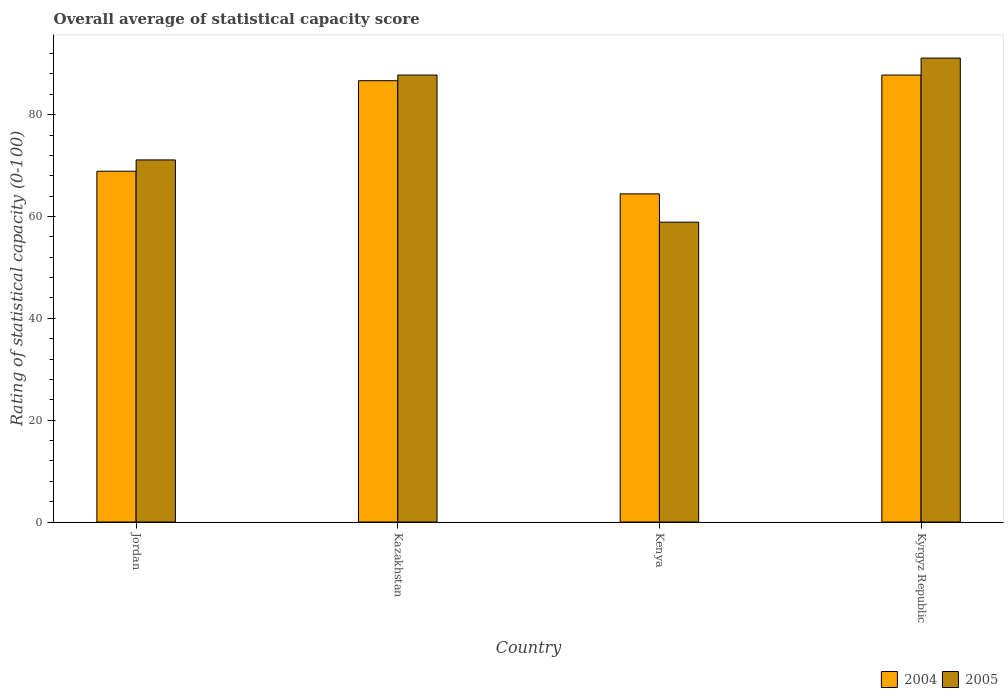How many different coloured bars are there?
Your response must be concise. 2. How many groups of bars are there?
Your answer should be compact. 4. Are the number of bars per tick equal to the number of legend labels?
Provide a short and direct response. Yes. What is the label of the 4th group of bars from the left?
Your answer should be very brief. Kyrgyz Republic. What is the rating of statistical capacity in 2005 in Kazakhstan?
Make the answer very short. 87.78. Across all countries, what is the maximum rating of statistical capacity in 2004?
Your answer should be compact. 87.78. Across all countries, what is the minimum rating of statistical capacity in 2005?
Your answer should be compact. 58.89. In which country was the rating of statistical capacity in 2004 maximum?
Keep it short and to the point. Kyrgyz Republic. In which country was the rating of statistical capacity in 2005 minimum?
Your answer should be compact. Kenya. What is the total rating of statistical capacity in 2005 in the graph?
Offer a very short reply. 308.89. What is the difference between the rating of statistical capacity in 2004 in Kazakhstan and that in Kyrgyz Republic?
Provide a short and direct response. -1.11. What is the difference between the rating of statistical capacity in 2005 in Jordan and the rating of statistical capacity in 2004 in Kyrgyz Republic?
Ensure brevity in your answer.  -16.67. What is the average rating of statistical capacity in 2005 per country?
Ensure brevity in your answer.  77.22. What is the difference between the rating of statistical capacity of/in 2004 and rating of statistical capacity of/in 2005 in Jordan?
Keep it short and to the point. -2.22. What is the ratio of the rating of statistical capacity in 2005 in Kazakhstan to that in Kenya?
Provide a succinct answer. 1.49. Is the rating of statistical capacity in 2004 in Jordan less than that in Kazakhstan?
Ensure brevity in your answer.  Yes. What is the difference between the highest and the second highest rating of statistical capacity in 2004?
Provide a succinct answer. -17.78. What is the difference between the highest and the lowest rating of statistical capacity in 2005?
Your response must be concise. 32.22. In how many countries, is the rating of statistical capacity in 2004 greater than the average rating of statistical capacity in 2004 taken over all countries?
Ensure brevity in your answer.  2. Is the sum of the rating of statistical capacity in 2005 in Kenya and Kyrgyz Republic greater than the maximum rating of statistical capacity in 2004 across all countries?
Give a very brief answer. Yes. What does the 1st bar from the left in Kazakhstan represents?
Provide a short and direct response. 2004. Are all the bars in the graph horizontal?
Make the answer very short. No. How many countries are there in the graph?
Keep it short and to the point. 4. Are the values on the major ticks of Y-axis written in scientific E-notation?
Your response must be concise. No. Does the graph contain any zero values?
Keep it short and to the point. No. Does the graph contain grids?
Ensure brevity in your answer.  No. How are the legend labels stacked?
Provide a short and direct response. Horizontal. What is the title of the graph?
Provide a short and direct response. Overall average of statistical capacity score. Does "1990" appear as one of the legend labels in the graph?
Provide a short and direct response. No. What is the label or title of the Y-axis?
Keep it short and to the point. Rating of statistical capacity (0-100). What is the Rating of statistical capacity (0-100) in 2004 in Jordan?
Keep it short and to the point. 68.89. What is the Rating of statistical capacity (0-100) in 2005 in Jordan?
Provide a succinct answer. 71.11. What is the Rating of statistical capacity (0-100) of 2004 in Kazakhstan?
Ensure brevity in your answer.  86.67. What is the Rating of statistical capacity (0-100) of 2005 in Kazakhstan?
Ensure brevity in your answer.  87.78. What is the Rating of statistical capacity (0-100) in 2004 in Kenya?
Keep it short and to the point. 64.44. What is the Rating of statistical capacity (0-100) of 2005 in Kenya?
Ensure brevity in your answer.  58.89. What is the Rating of statistical capacity (0-100) in 2004 in Kyrgyz Republic?
Ensure brevity in your answer.  87.78. What is the Rating of statistical capacity (0-100) of 2005 in Kyrgyz Republic?
Ensure brevity in your answer.  91.11. Across all countries, what is the maximum Rating of statistical capacity (0-100) of 2004?
Offer a very short reply. 87.78. Across all countries, what is the maximum Rating of statistical capacity (0-100) in 2005?
Ensure brevity in your answer.  91.11. Across all countries, what is the minimum Rating of statistical capacity (0-100) in 2004?
Provide a short and direct response. 64.44. Across all countries, what is the minimum Rating of statistical capacity (0-100) of 2005?
Keep it short and to the point. 58.89. What is the total Rating of statistical capacity (0-100) of 2004 in the graph?
Your answer should be very brief. 307.78. What is the total Rating of statistical capacity (0-100) in 2005 in the graph?
Your answer should be compact. 308.89. What is the difference between the Rating of statistical capacity (0-100) of 2004 in Jordan and that in Kazakhstan?
Give a very brief answer. -17.78. What is the difference between the Rating of statistical capacity (0-100) of 2005 in Jordan and that in Kazakhstan?
Ensure brevity in your answer.  -16.67. What is the difference between the Rating of statistical capacity (0-100) of 2004 in Jordan and that in Kenya?
Ensure brevity in your answer.  4.44. What is the difference between the Rating of statistical capacity (0-100) of 2005 in Jordan and that in Kenya?
Keep it short and to the point. 12.22. What is the difference between the Rating of statistical capacity (0-100) of 2004 in Jordan and that in Kyrgyz Republic?
Keep it short and to the point. -18.89. What is the difference between the Rating of statistical capacity (0-100) in 2004 in Kazakhstan and that in Kenya?
Your answer should be compact. 22.22. What is the difference between the Rating of statistical capacity (0-100) of 2005 in Kazakhstan and that in Kenya?
Provide a short and direct response. 28.89. What is the difference between the Rating of statistical capacity (0-100) in 2004 in Kazakhstan and that in Kyrgyz Republic?
Keep it short and to the point. -1.11. What is the difference between the Rating of statistical capacity (0-100) in 2004 in Kenya and that in Kyrgyz Republic?
Offer a very short reply. -23.33. What is the difference between the Rating of statistical capacity (0-100) in 2005 in Kenya and that in Kyrgyz Republic?
Offer a very short reply. -32.22. What is the difference between the Rating of statistical capacity (0-100) of 2004 in Jordan and the Rating of statistical capacity (0-100) of 2005 in Kazakhstan?
Offer a terse response. -18.89. What is the difference between the Rating of statistical capacity (0-100) in 2004 in Jordan and the Rating of statistical capacity (0-100) in 2005 in Kyrgyz Republic?
Keep it short and to the point. -22.22. What is the difference between the Rating of statistical capacity (0-100) in 2004 in Kazakhstan and the Rating of statistical capacity (0-100) in 2005 in Kenya?
Keep it short and to the point. 27.78. What is the difference between the Rating of statistical capacity (0-100) in 2004 in Kazakhstan and the Rating of statistical capacity (0-100) in 2005 in Kyrgyz Republic?
Ensure brevity in your answer.  -4.44. What is the difference between the Rating of statistical capacity (0-100) in 2004 in Kenya and the Rating of statistical capacity (0-100) in 2005 in Kyrgyz Republic?
Your answer should be very brief. -26.67. What is the average Rating of statistical capacity (0-100) in 2004 per country?
Give a very brief answer. 76.94. What is the average Rating of statistical capacity (0-100) of 2005 per country?
Your response must be concise. 77.22. What is the difference between the Rating of statistical capacity (0-100) of 2004 and Rating of statistical capacity (0-100) of 2005 in Jordan?
Provide a short and direct response. -2.22. What is the difference between the Rating of statistical capacity (0-100) in 2004 and Rating of statistical capacity (0-100) in 2005 in Kazakhstan?
Ensure brevity in your answer.  -1.11. What is the difference between the Rating of statistical capacity (0-100) of 2004 and Rating of statistical capacity (0-100) of 2005 in Kenya?
Ensure brevity in your answer.  5.56. What is the ratio of the Rating of statistical capacity (0-100) of 2004 in Jordan to that in Kazakhstan?
Your answer should be very brief. 0.79. What is the ratio of the Rating of statistical capacity (0-100) of 2005 in Jordan to that in Kazakhstan?
Make the answer very short. 0.81. What is the ratio of the Rating of statistical capacity (0-100) in 2004 in Jordan to that in Kenya?
Ensure brevity in your answer.  1.07. What is the ratio of the Rating of statistical capacity (0-100) of 2005 in Jordan to that in Kenya?
Offer a terse response. 1.21. What is the ratio of the Rating of statistical capacity (0-100) in 2004 in Jordan to that in Kyrgyz Republic?
Offer a terse response. 0.78. What is the ratio of the Rating of statistical capacity (0-100) of 2005 in Jordan to that in Kyrgyz Republic?
Give a very brief answer. 0.78. What is the ratio of the Rating of statistical capacity (0-100) in 2004 in Kazakhstan to that in Kenya?
Give a very brief answer. 1.34. What is the ratio of the Rating of statistical capacity (0-100) in 2005 in Kazakhstan to that in Kenya?
Provide a succinct answer. 1.49. What is the ratio of the Rating of statistical capacity (0-100) of 2004 in Kazakhstan to that in Kyrgyz Republic?
Ensure brevity in your answer.  0.99. What is the ratio of the Rating of statistical capacity (0-100) of 2005 in Kazakhstan to that in Kyrgyz Republic?
Your answer should be very brief. 0.96. What is the ratio of the Rating of statistical capacity (0-100) in 2004 in Kenya to that in Kyrgyz Republic?
Your answer should be very brief. 0.73. What is the ratio of the Rating of statistical capacity (0-100) of 2005 in Kenya to that in Kyrgyz Republic?
Give a very brief answer. 0.65. What is the difference between the highest and the second highest Rating of statistical capacity (0-100) of 2004?
Offer a terse response. 1.11. What is the difference between the highest and the second highest Rating of statistical capacity (0-100) in 2005?
Ensure brevity in your answer.  3.33. What is the difference between the highest and the lowest Rating of statistical capacity (0-100) in 2004?
Ensure brevity in your answer.  23.33. What is the difference between the highest and the lowest Rating of statistical capacity (0-100) in 2005?
Your answer should be compact. 32.22. 